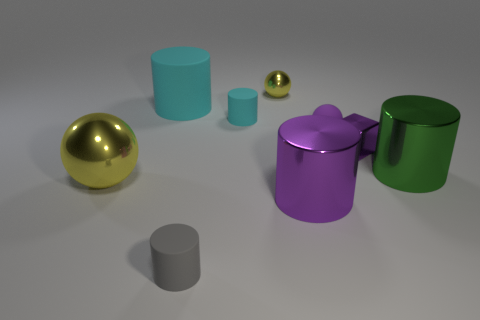Are there any patterns or designs on any of the objects? No, all the objects are of solid colors and do not have any patterns or designs on them. The objects are simple in shape and uniformly colored. Could you describe the smallest object in the scene? The smallest object appears to be a tiny gold-colored sphere to the right of the cyan cylinder, next to the small metallic sphere. 